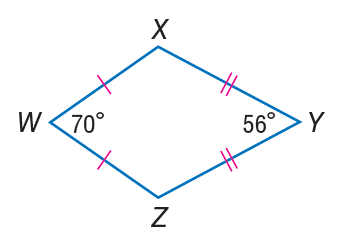Answer the mathemtical geometry problem and directly provide the correct option letter.
Question: Find m \angle X.
Choices: A: 14 B: 56 C: 70 D: 117 D 